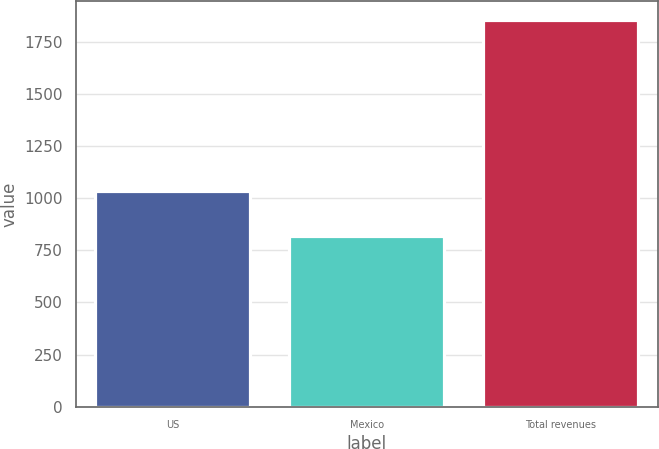Convert chart. <chart><loc_0><loc_0><loc_500><loc_500><bar_chart><fcel>US<fcel>Mexico<fcel>Total revenues<nl><fcel>1033.6<fcel>818.5<fcel>1852.1<nl></chart> 